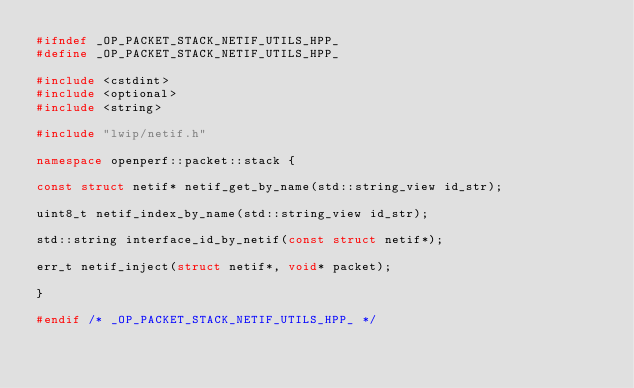Convert code to text. <code><loc_0><loc_0><loc_500><loc_500><_C++_>#ifndef _OP_PACKET_STACK_NETIF_UTILS_HPP_
#define _OP_PACKET_STACK_NETIF_UTILS_HPP_

#include <cstdint>
#include <optional>
#include <string>

#include "lwip/netif.h"

namespace openperf::packet::stack {

const struct netif* netif_get_by_name(std::string_view id_str);

uint8_t netif_index_by_name(std::string_view id_str);

std::string interface_id_by_netif(const struct netif*);

err_t netif_inject(struct netif*, void* packet);

}

#endif /* _OP_PACKET_STACK_NETIF_UTILS_HPP_ */
</code> 